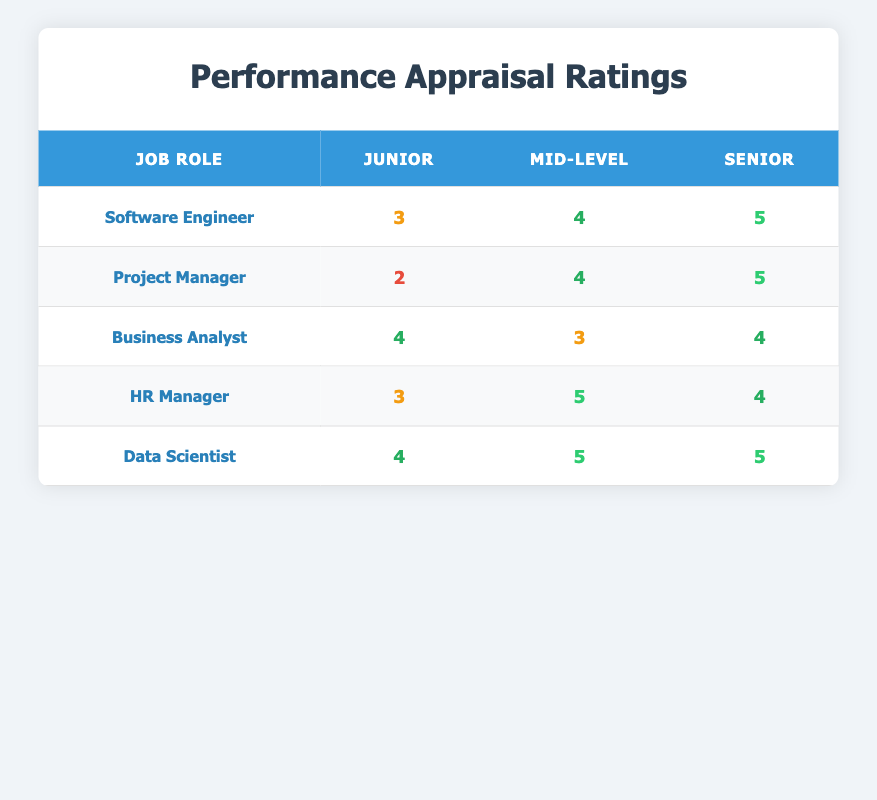What is the performance appraisal rating for Junior Project Managers? According to the table, the rating for Junior Project Managers is listed under the Junior column for the Project Manager job role, which shows a rating of 2.
Answer: 2 Which job role has the highest rating at the Senior level? Looking at the table, we see the Senior ratings for each job role: Software Engineer (5), Project Manager (5), Business Analyst (4), HR Manager (4), and Data Scientist (5). The highest rating at the Senior level is 5, seen in Software Engineer, Project Manager, and Data Scientist.
Answer: 5 What is the average performance rating for Mid-level roles? The Mid-level ratings from the table are: Software Engineer (4), Project Manager (4), Business Analyst (3), HR Manager (5), and Data Scientist (5). To find the average, sum these ratings: 4 + 4 + 3 + 5 + 5 = 21. Divide by the number of roles (5): 21/5 = 4.2.
Answer: 4.2 Is the rating for Junior Data Scientists higher than that of Junior Software Engineers? The rating for Junior Data Scientists is 4, while the rating for Junior Software Engineers is 3. Since 4 is greater than 3, the statement is true.
Answer: Yes Which job role has the lowest average rating across all experience levels? First, we calculate the average ratings for each job role: Software Engineer: (3+4+5)/3 = 4, Project Manager: (2+4+5)/3 = 3.67, Business Analyst: (4+3+4)/3 = 3.67, HR Manager: (3+5+4)/3 = 4, Data Scientist: (4+5+5)/3 = 4.67. The lowest average rating is 3.67 for both Project Manager and Business Analyst.
Answer: Project Manager and Business Analyst 